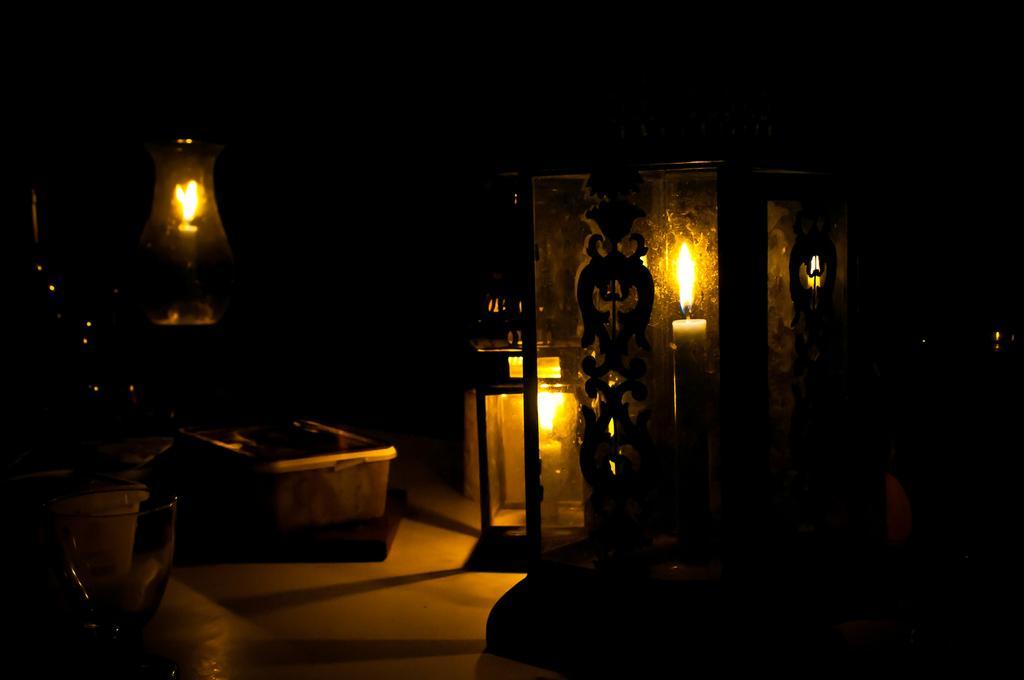Could you give a brief overview of what you see in this image? In this picture we can see lighted candles, box, glass and some objects and in the background it is dark. 